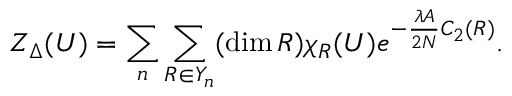<formula> <loc_0><loc_0><loc_500><loc_500>Z _ { \Delta } ( U ) = \sum _ { n } \sum _ { R \in Y _ { n } } ( \dim R ) \chi _ { R } ( U ) e ^ { - \frac { \lambda A } { 2 N } C _ { 2 } ( R ) } .</formula> 